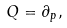<formula> <loc_0><loc_0><loc_500><loc_500>Q = \partial _ { p } ,</formula> 